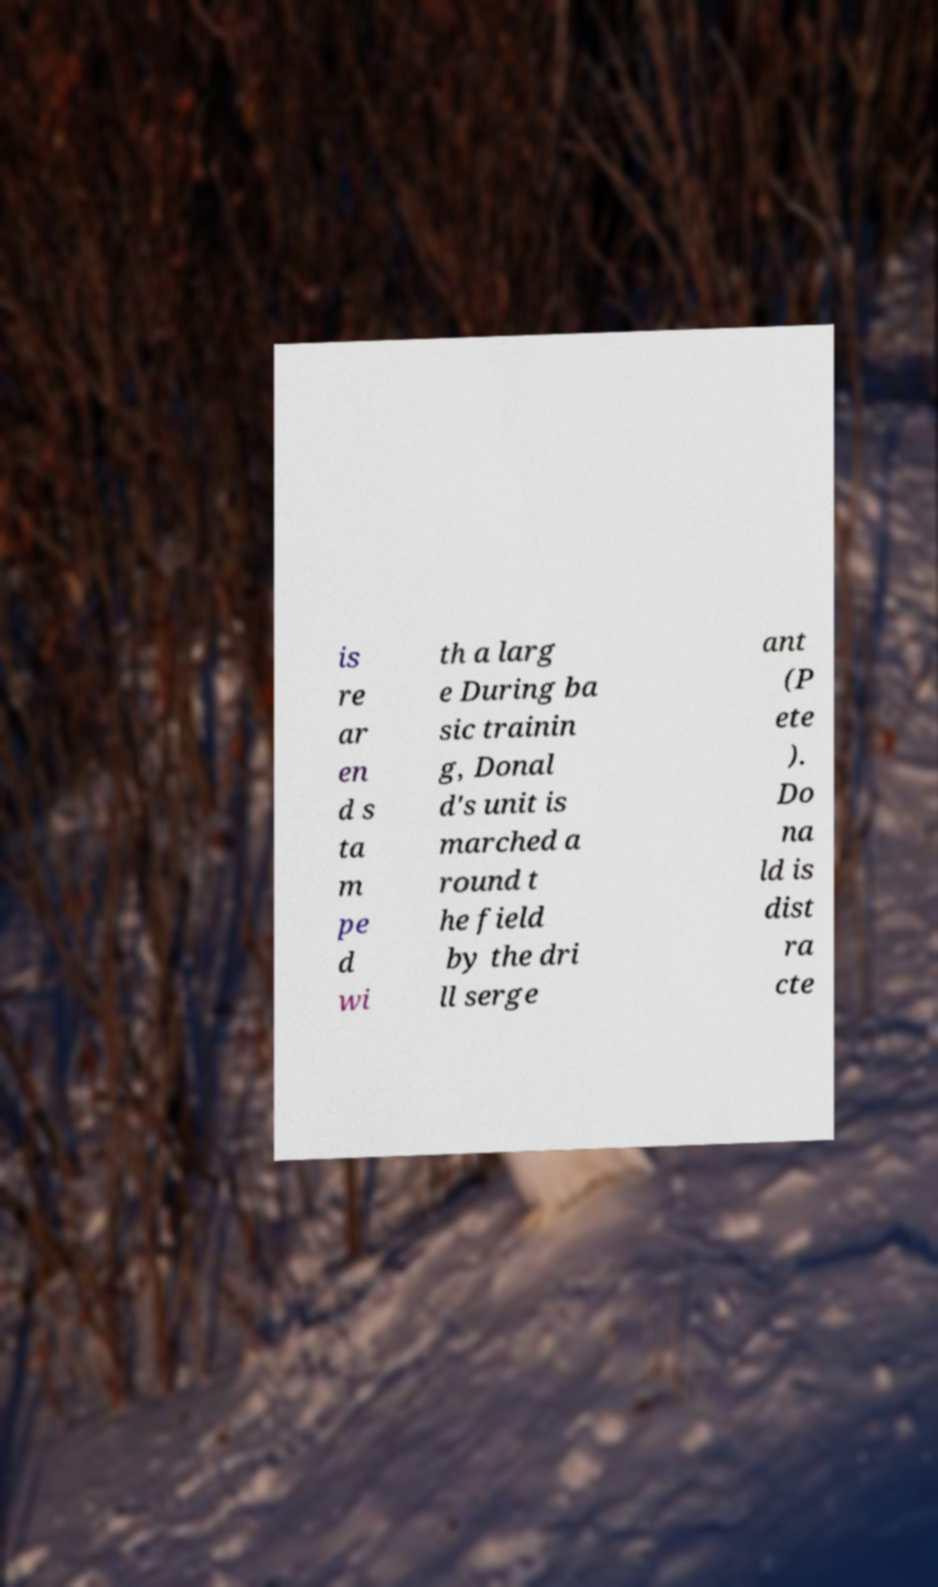Please read and relay the text visible in this image. What does it say? is re ar en d s ta m pe d wi th a larg e During ba sic trainin g, Donal d's unit is marched a round t he field by the dri ll serge ant (P ete ). Do na ld is dist ra cte 